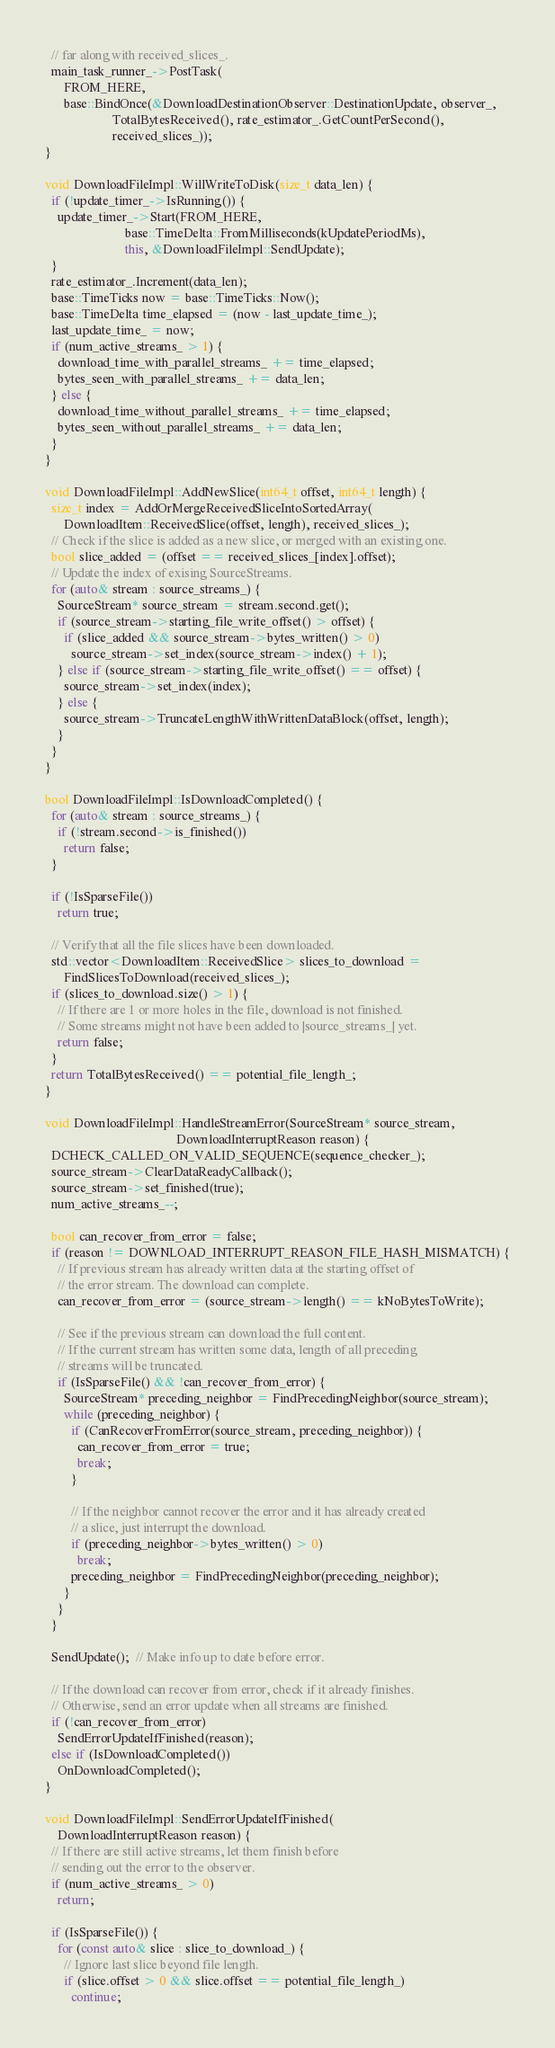Convert code to text. <code><loc_0><loc_0><loc_500><loc_500><_C++_>  // far along with received_slices_.
  main_task_runner_->PostTask(
      FROM_HERE,
      base::BindOnce(&DownloadDestinationObserver::DestinationUpdate, observer_,
                     TotalBytesReceived(), rate_estimator_.GetCountPerSecond(),
                     received_slices_));
}

void DownloadFileImpl::WillWriteToDisk(size_t data_len) {
  if (!update_timer_->IsRunning()) {
    update_timer_->Start(FROM_HERE,
                         base::TimeDelta::FromMilliseconds(kUpdatePeriodMs),
                         this, &DownloadFileImpl::SendUpdate);
  }
  rate_estimator_.Increment(data_len);
  base::TimeTicks now = base::TimeTicks::Now();
  base::TimeDelta time_elapsed = (now - last_update_time_);
  last_update_time_ = now;
  if (num_active_streams_ > 1) {
    download_time_with_parallel_streams_ += time_elapsed;
    bytes_seen_with_parallel_streams_ += data_len;
  } else {
    download_time_without_parallel_streams_ += time_elapsed;
    bytes_seen_without_parallel_streams_ += data_len;
  }
}

void DownloadFileImpl::AddNewSlice(int64_t offset, int64_t length) {
  size_t index = AddOrMergeReceivedSliceIntoSortedArray(
      DownloadItem::ReceivedSlice(offset, length), received_slices_);
  // Check if the slice is added as a new slice, or merged with an existing one.
  bool slice_added = (offset == received_slices_[index].offset);
  // Update the index of exising SourceStreams.
  for (auto& stream : source_streams_) {
    SourceStream* source_stream = stream.second.get();
    if (source_stream->starting_file_write_offset() > offset) {
      if (slice_added && source_stream->bytes_written() > 0)
        source_stream->set_index(source_stream->index() + 1);
    } else if (source_stream->starting_file_write_offset() == offset) {
      source_stream->set_index(index);
    } else {
      source_stream->TruncateLengthWithWrittenDataBlock(offset, length);
    }
  }
}

bool DownloadFileImpl::IsDownloadCompleted() {
  for (auto& stream : source_streams_) {
    if (!stream.second->is_finished())
      return false;
  }

  if (!IsSparseFile())
    return true;

  // Verify that all the file slices have been downloaded.
  std::vector<DownloadItem::ReceivedSlice> slices_to_download =
      FindSlicesToDownload(received_slices_);
  if (slices_to_download.size() > 1) {
    // If there are 1 or more holes in the file, download is not finished.
    // Some streams might not have been added to |source_streams_| yet.
    return false;
  }
  return TotalBytesReceived() == potential_file_length_;
}

void DownloadFileImpl::HandleStreamError(SourceStream* source_stream,
                                         DownloadInterruptReason reason) {
  DCHECK_CALLED_ON_VALID_SEQUENCE(sequence_checker_);
  source_stream->ClearDataReadyCallback();
  source_stream->set_finished(true);
  num_active_streams_--;

  bool can_recover_from_error = false;
  if (reason != DOWNLOAD_INTERRUPT_REASON_FILE_HASH_MISMATCH) {
    // If previous stream has already written data at the starting offset of
    // the error stream. The download can complete.
    can_recover_from_error = (source_stream->length() == kNoBytesToWrite);

    // See if the previous stream can download the full content.
    // If the current stream has written some data, length of all preceding
    // streams will be truncated.
    if (IsSparseFile() && !can_recover_from_error) {
      SourceStream* preceding_neighbor = FindPrecedingNeighbor(source_stream);
      while (preceding_neighbor) {
        if (CanRecoverFromError(source_stream, preceding_neighbor)) {
          can_recover_from_error = true;
          break;
        }

        // If the neighbor cannot recover the error and it has already created
        // a slice, just interrupt the download.
        if (preceding_neighbor->bytes_written() > 0)
          break;
        preceding_neighbor = FindPrecedingNeighbor(preceding_neighbor);
      }
    }
  }

  SendUpdate();  // Make info up to date before error.

  // If the download can recover from error, check if it already finishes.
  // Otherwise, send an error update when all streams are finished.
  if (!can_recover_from_error)
    SendErrorUpdateIfFinished(reason);
  else if (IsDownloadCompleted())
    OnDownloadCompleted();
}

void DownloadFileImpl::SendErrorUpdateIfFinished(
    DownloadInterruptReason reason) {
  // If there are still active streams, let them finish before
  // sending out the error to the observer.
  if (num_active_streams_ > 0)
    return;

  if (IsSparseFile()) {
    for (const auto& slice : slice_to_download_) {
      // Ignore last slice beyond file length.
      if (slice.offset > 0 && slice.offset == potential_file_length_)
        continue;</code> 